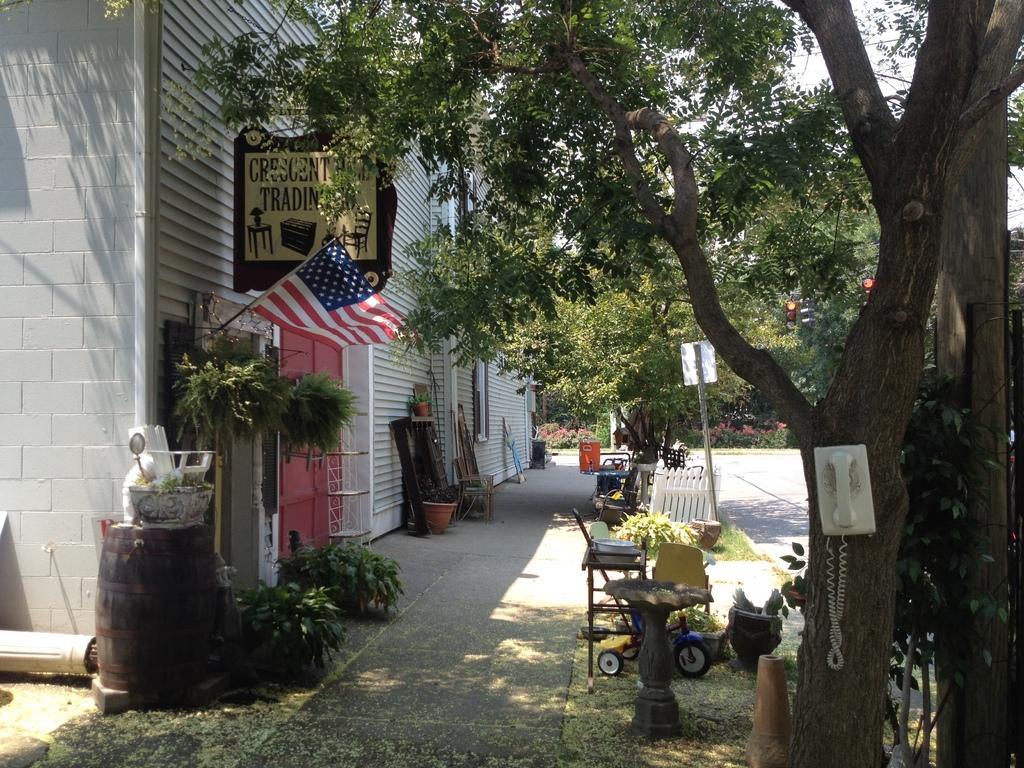How would you summarize this image in a sentence or two? In this picture we can see telephone on tree, plants, pots, flag, objects on barrel, bicycle, chair, boards, pole, fence, building and objects. In the background of the image we can see trees, traffic signals, plants and sky. 